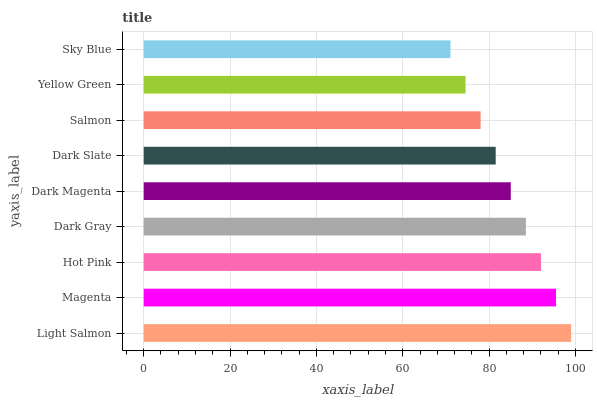Is Sky Blue the minimum?
Answer yes or no. Yes. Is Light Salmon the maximum?
Answer yes or no. Yes. Is Magenta the minimum?
Answer yes or no. No. Is Magenta the maximum?
Answer yes or no. No. Is Light Salmon greater than Magenta?
Answer yes or no. Yes. Is Magenta less than Light Salmon?
Answer yes or no. Yes. Is Magenta greater than Light Salmon?
Answer yes or no. No. Is Light Salmon less than Magenta?
Answer yes or no. No. Is Dark Magenta the high median?
Answer yes or no. Yes. Is Dark Magenta the low median?
Answer yes or no. Yes. Is Sky Blue the high median?
Answer yes or no. No. Is Dark Slate the low median?
Answer yes or no. No. 